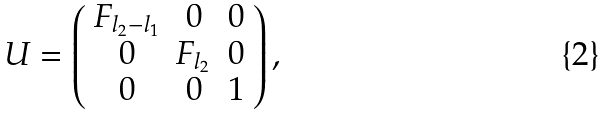<formula> <loc_0><loc_0><loc_500><loc_500>U = \left ( \begin{array} { c c c } F _ { l _ { 2 } - l _ { 1 } } & 0 & 0 \\ 0 & F _ { l _ { 2 } } & 0 \\ 0 & 0 & 1 \end{array} \right ) ,</formula> 